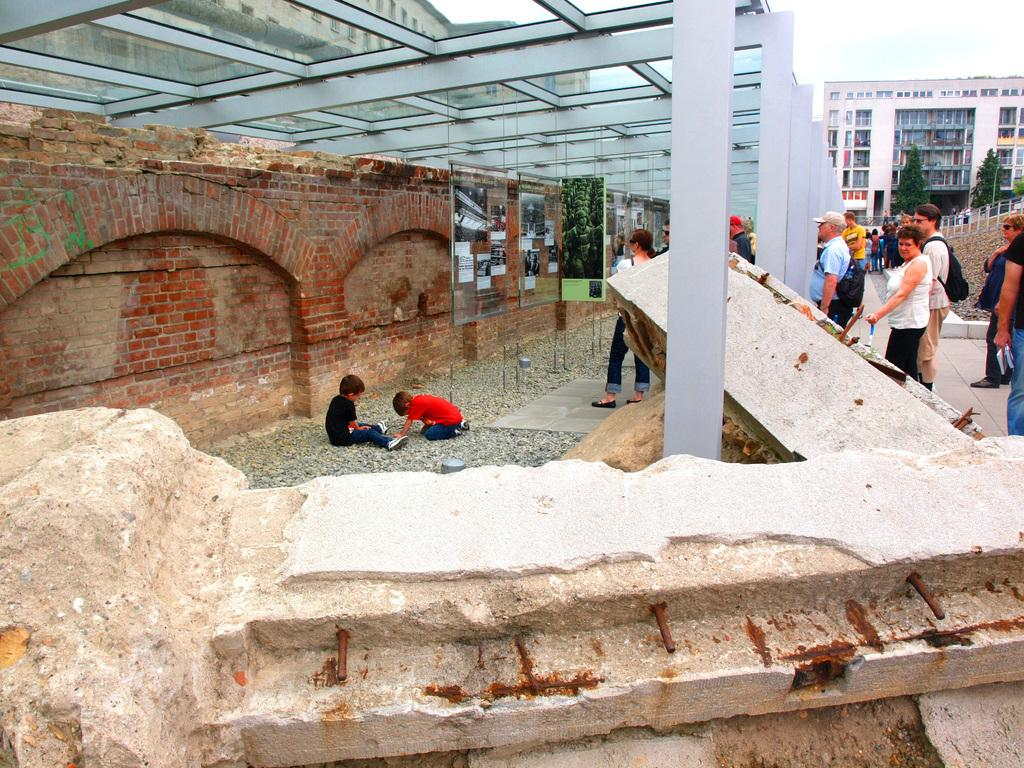How many people are in the image? There are people in the image, but the exact number is not specified. What are some people wearing in the image? Some people are wearing bags in the image. What type of structures can be seen in the image? There are buildings and a brick wall present in the image. What natural elements are visible in the image? Trees and the sky are visible in the image. What architectural features can be observed in the image? Windows and fencing are visible in the image. What is the color of the sky in the image? The sky is blue and white in color. What type of stew is being served in the image? There is no stew present in the image. What is the relationship between the people in the image? The facts provided do not give any information about the relationships between the people in the image. 